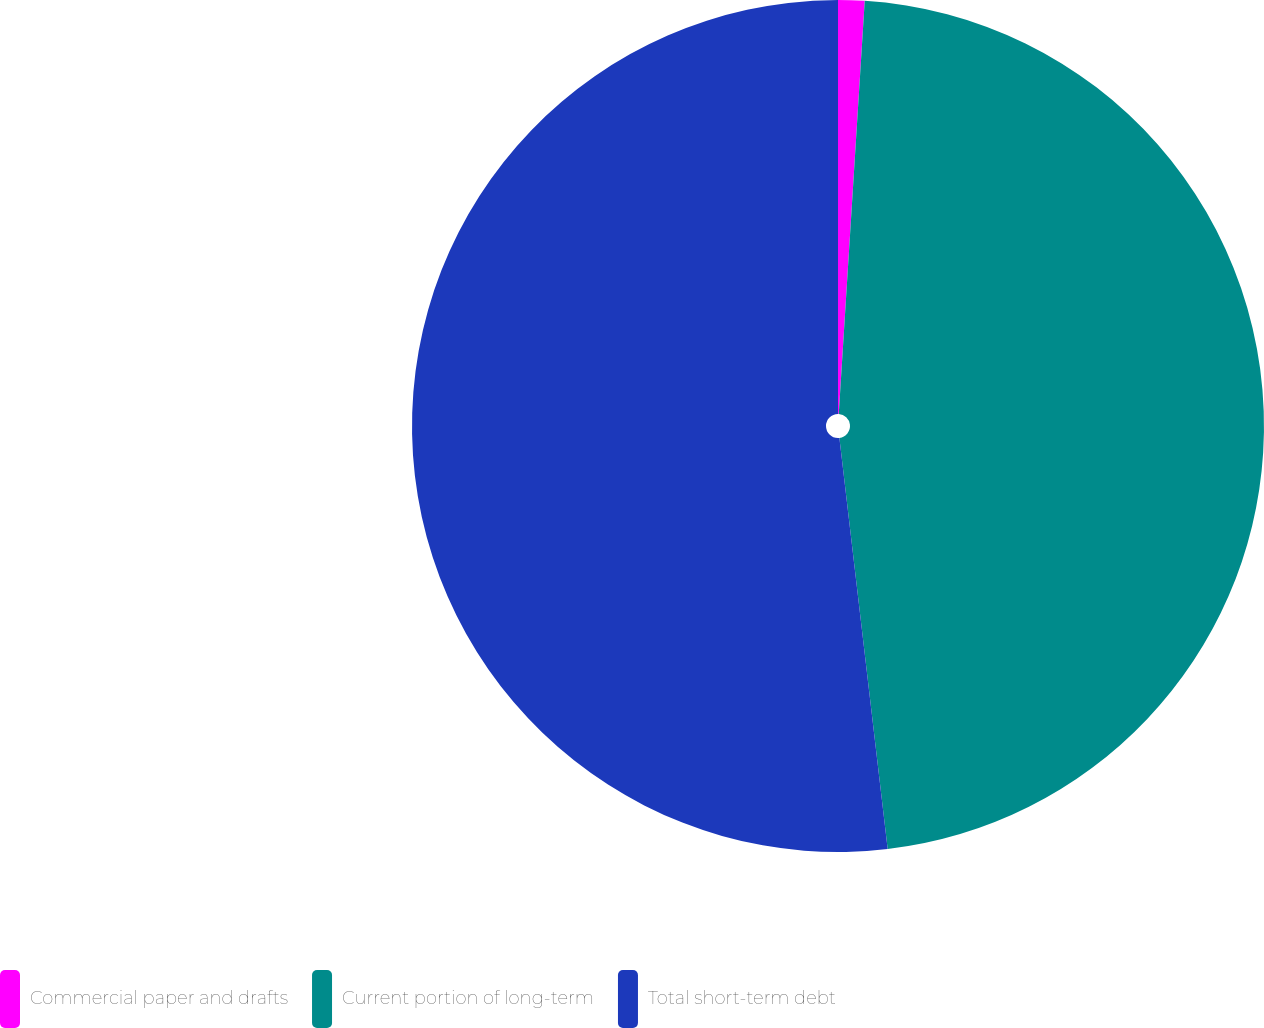<chart> <loc_0><loc_0><loc_500><loc_500><pie_chart><fcel>Commercial paper and drafts<fcel>Current portion of long-term<fcel>Total short-term debt<nl><fcel>1.0%<fcel>47.14%<fcel>51.86%<nl></chart> 